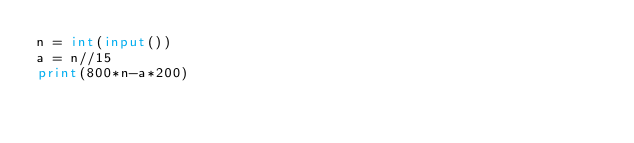<code> <loc_0><loc_0><loc_500><loc_500><_Python_>n = int(input())
a = n//15
print(800*n-a*200)
</code> 